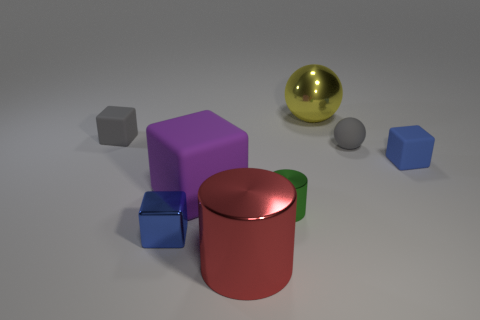The other shiny thing that is the same shape as the big purple thing is what color?
Your response must be concise. Blue. What size is the yellow metallic object?
Ensure brevity in your answer.  Large. What is the color of the rubber ball that is behind the tiny block that is right of the tiny green metal thing?
Give a very brief answer. Gray. What number of cubes are left of the metal block and right of the rubber ball?
Provide a short and direct response. 0. Is the number of metal spheres greater than the number of blue cubes?
Keep it short and to the point. No. What is the material of the small gray block?
Provide a short and direct response. Rubber. What number of small gray things are in front of the gray thing to the left of the blue metal block?
Offer a terse response. 1. Is the color of the matte sphere the same as the small matte thing that is on the left side of the red cylinder?
Keep it short and to the point. Yes. What is the color of the matte sphere that is the same size as the blue rubber block?
Keep it short and to the point. Gray. Is there another metal thing that has the same shape as the green shiny thing?
Offer a terse response. Yes. 